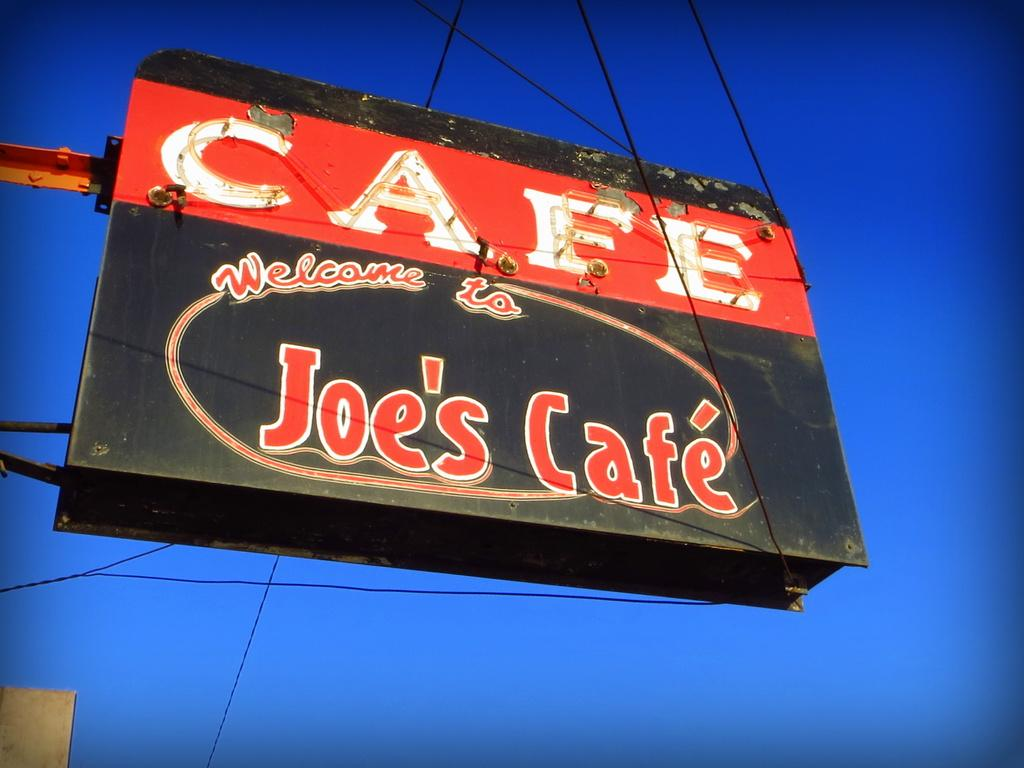<image>
Give a short and clear explanation of the subsequent image. A black and red sign for Joe's Cafe is outside. 